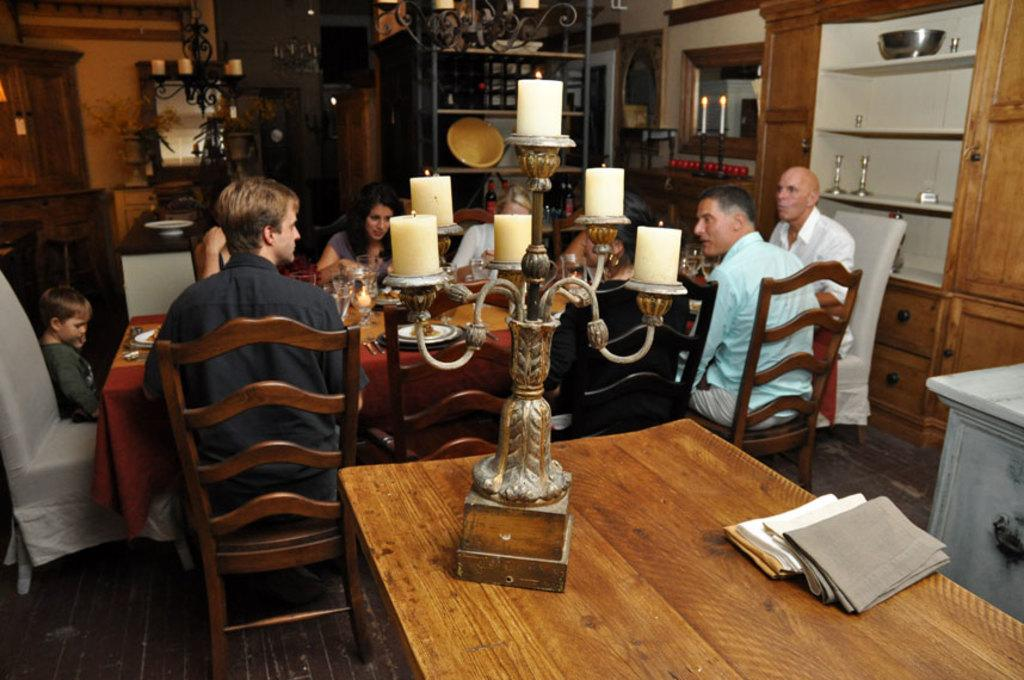What type of structure can be seen in the image? There is a wall in the image. What is used for reflecting images in the image? There is a mirror in the image. What is used for holding objects in the image? There are shelves in the image. What is used for providing light in the image? There are candles in the image. What are the people in the image doing? There are people sitting on chairs in the image. What piece of furniture is present in the image? There is a table in the image. What is used for covering the table in the image? There are cloths on the table. What is used for serving food in the image? There are plates on the table. What is used for holding liquids in the image? There are glasses on the table. Where are the boys playing in the image? There is no mention of boys or any playing activity in the image. What type of musical instruments are the band members playing in the image? There is no mention of a band or any musical instruments in the image. 